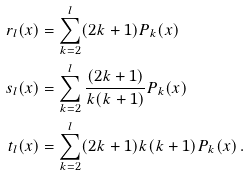Convert formula to latex. <formula><loc_0><loc_0><loc_500><loc_500>r _ { l } ( x ) & = \sum _ { k = 2 } ^ { l } ( 2 k + 1 ) P _ { k } ( x ) \\ s _ { l } ( x ) & = \sum _ { k = 2 } ^ { l } \frac { ( 2 k + 1 ) } { k ( k + 1 ) } P _ { k } ( x ) \\ t _ { l } ( x ) & = \sum _ { k = 2 } ^ { l } ( 2 k + 1 ) k ( k + 1 ) P _ { k } ( x ) \, .</formula> 